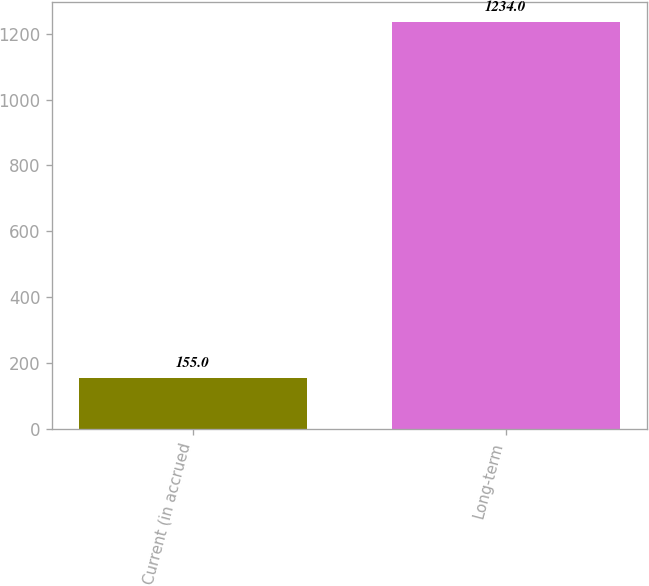Convert chart to OTSL. <chart><loc_0><loc_0><loc_500><loc_500><bar_chart><fcel>Current (in accrued<fcel>Long-term<nl><fcel>155<fcel>1234<nl></chart> 